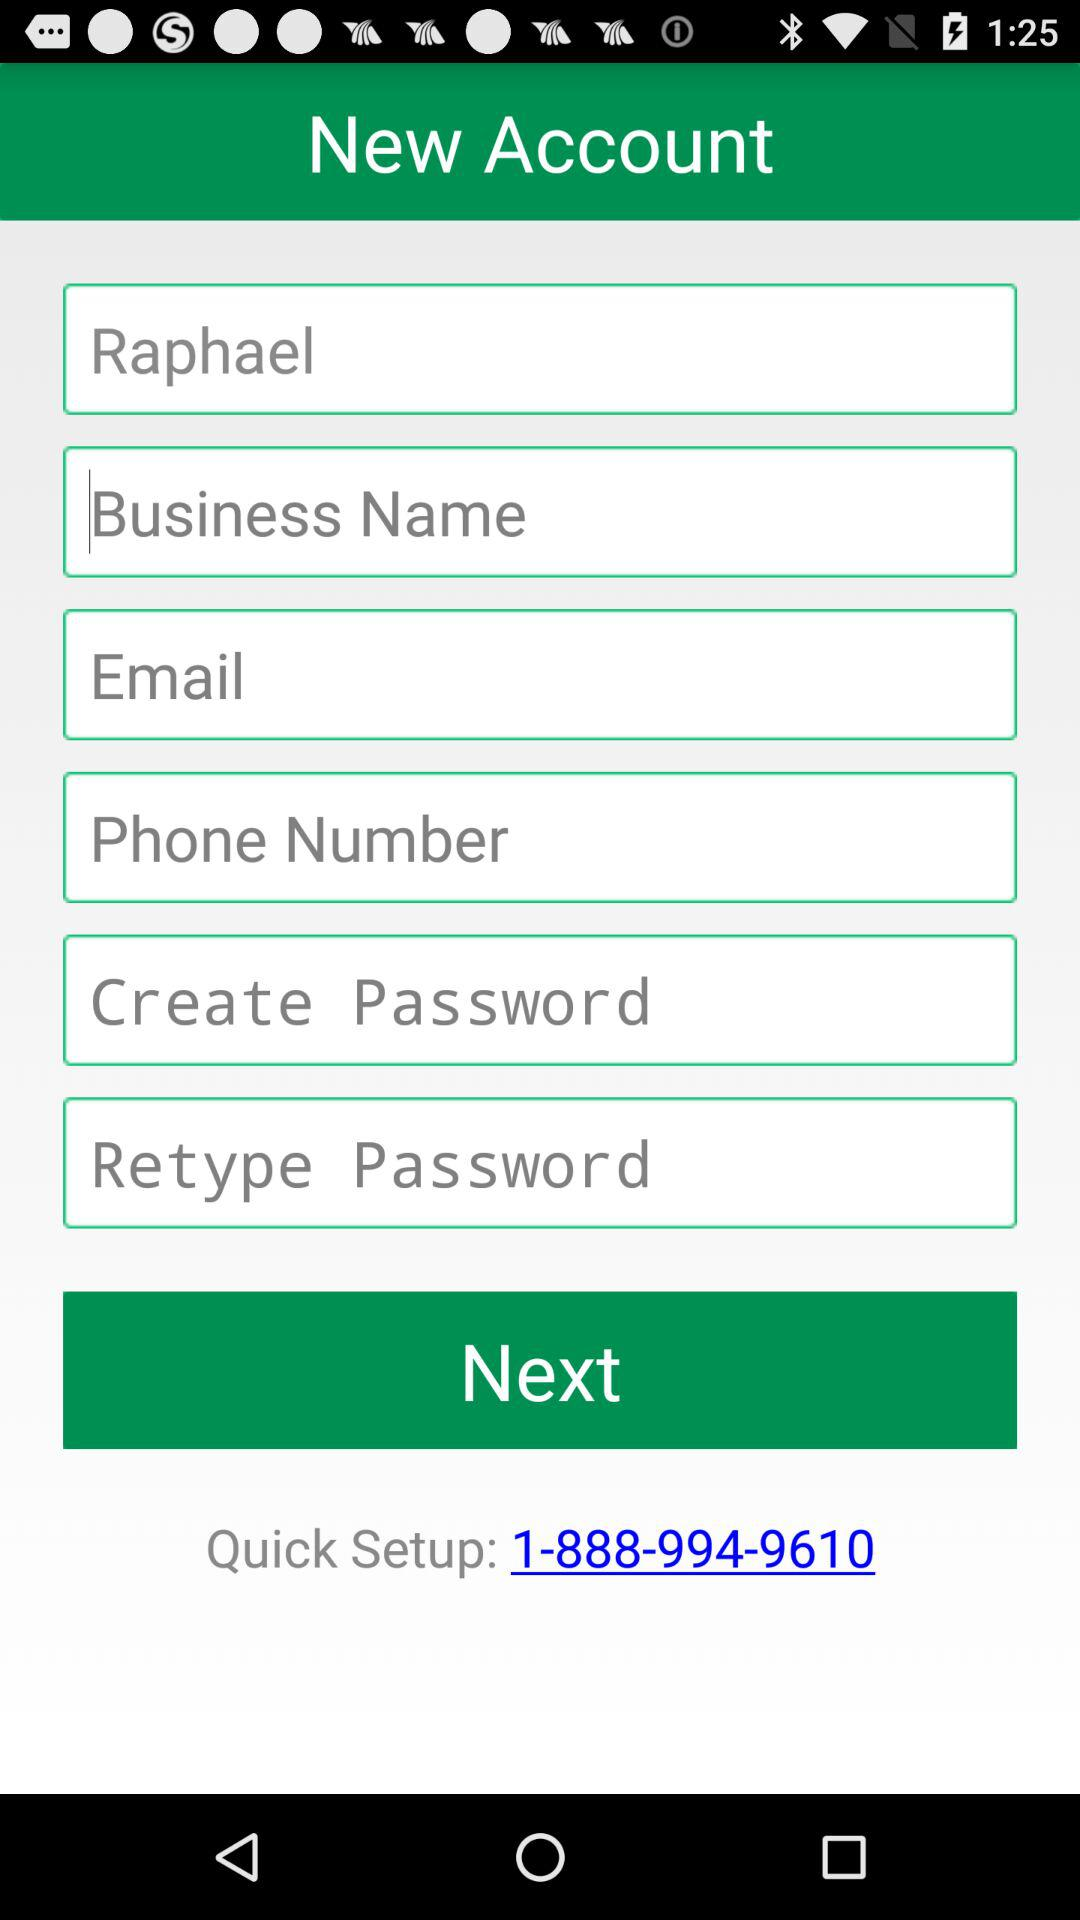How many input fields are there after the email field?
Answer the question using a single word or phrase. 3 